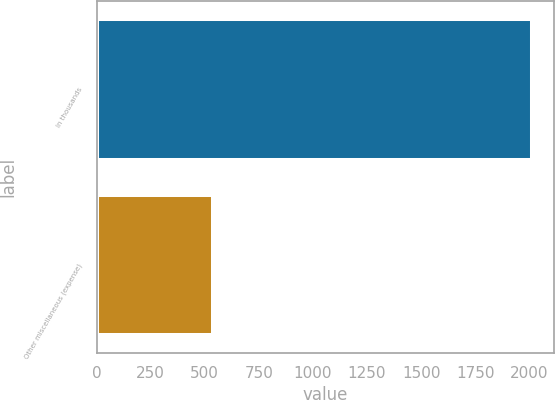<chart> <loc_0><loc_0><loc_500><loc_500><bar_chart><fcel>In thousands<fcel>Other miscellaneous (expense)<nl><fcel>2012<fcel>536<nl></chart> 